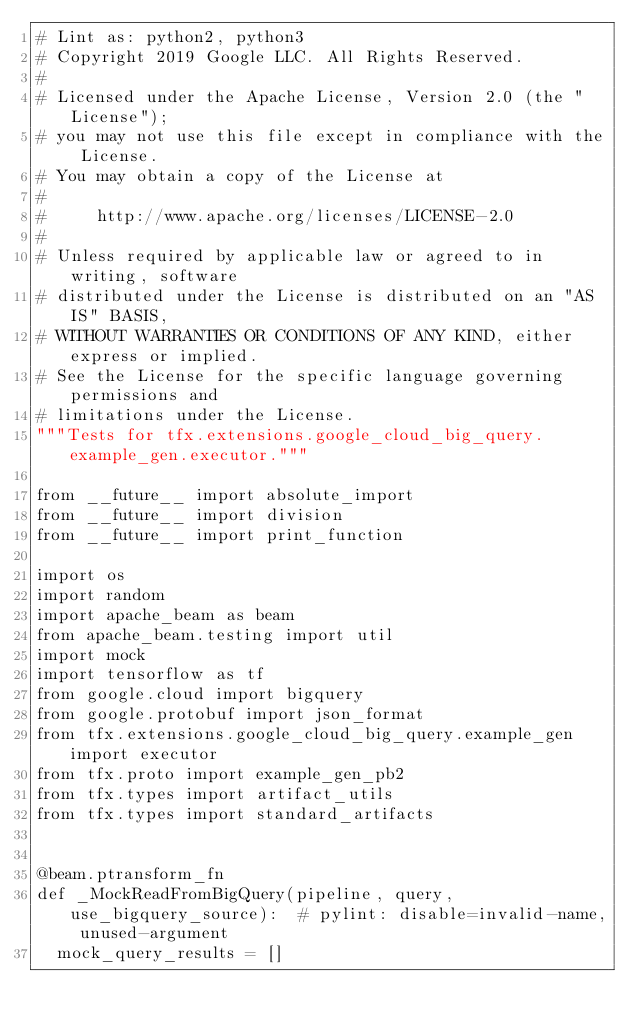<code> <loc_0><loc_0><loc_500><loc_500><_Python_># Lint as: python2, python3
# Copyright 2019 Google LLC. All Rights Reserved.
#
# Licensed under the Apache License, Version 2.0 (the "License");
# you may not use this file except in compliance with the License.
# You may obtain a copy of the License at
#
#     http://www.apache.org/licenses/LICENSE-2.0
#
# Unless required by applicable law or agreed to in writing, software
# distributed under the License is distributed on an "AS IS" BASIS,
# WITHOUT WARRANTIES OR CONDITIONS OF ANY KIND, either express or implied.
# See the License for the specific language governing permissions and
# limitations under the License.
"""Tests for tfx.extensions.google_cloud_big_query.example_gen.executor."""

from __future__ import absolute_import
from __future__ import division
from __future__ import print_function

import os
import random
import apache_beam as beam
from apache_beam.testing import util
import mock
import tensorflow as tf
from google.cloud import bigquery
from google.protobuf import json_format
from tfx.extensions.google_cloud_big_query.example_gen import executor
from tfx.proto import example_gen_pb2
from tfx.types import artifact_utils
from tfx.types import standard_artifacts


@beam.ptransform_fn
def _MockReadFromBigQuery(pipeline, query, use_bigquery_source):  # pylint: disable=invalid-name, unused-argument
  mock_query_results = []</code> 